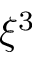<formula> <loc_0><loc_0><loc_500><loc_500>\xi ^ { 3 }</formula> 